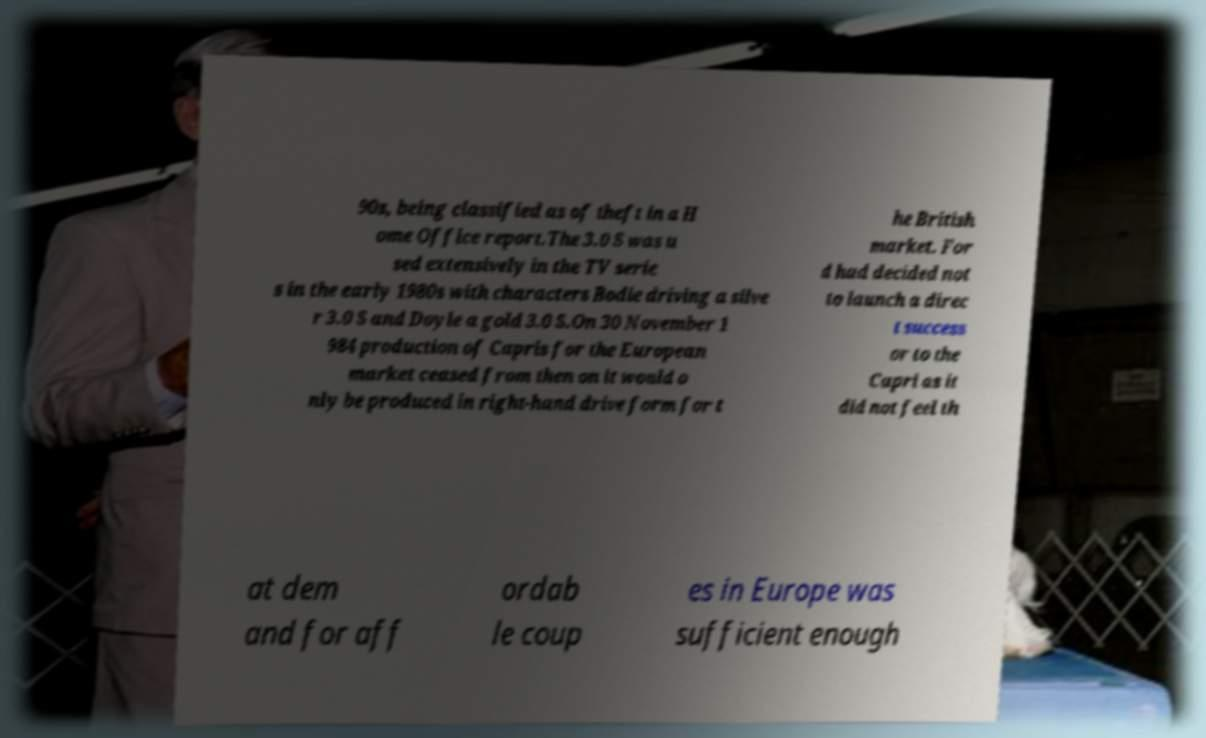Please identify and transcribe the text found in this image. 90s, being classified as of theft in a H ome Office report.The 3.0 S was u sed extensively in the TV serie s in the early 1980s with characters Bodie driving a silve r 3.0 S and Doyle a gold 3.0 S.On 30 November 1 984 production of Capris for the European market ceased from then on it would o nly be produced in right-hand drive form for t he British market. For d had decided not to launch a direc t success or to the Capri as it did not feel th at dem and for aff ordab le coup es in Europe was sufficient enough 